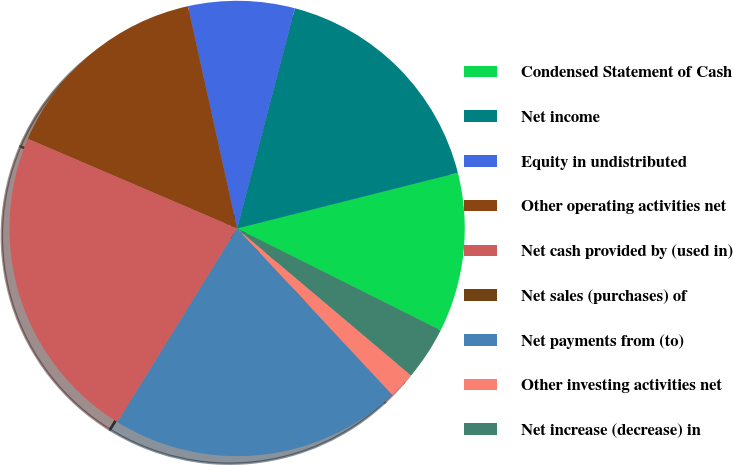Convert chart to OTSL. <chart><loc_0><loc_0><loc_500><loc_500><pie_chart><fcel>Condensed Statement of Cash<fcel>Net income<fcel>Equity in undistributed<fcel>Other operating activities net<fcel>Net cash provided by (used in)<fcel>Net sales (purchases) of<fcel>Net payments from (to)<fcel>Other investing activities net<fcel>Net increase (decrease) in<nl><fcel>11.32%<fcel>16.98%<fcel>7.55%<fcel>15.09%<fcel>22.64%<fcel>0.0%<fcel>20.75%<fcel>1.89%<fcel>3.77%<nl></chart> 